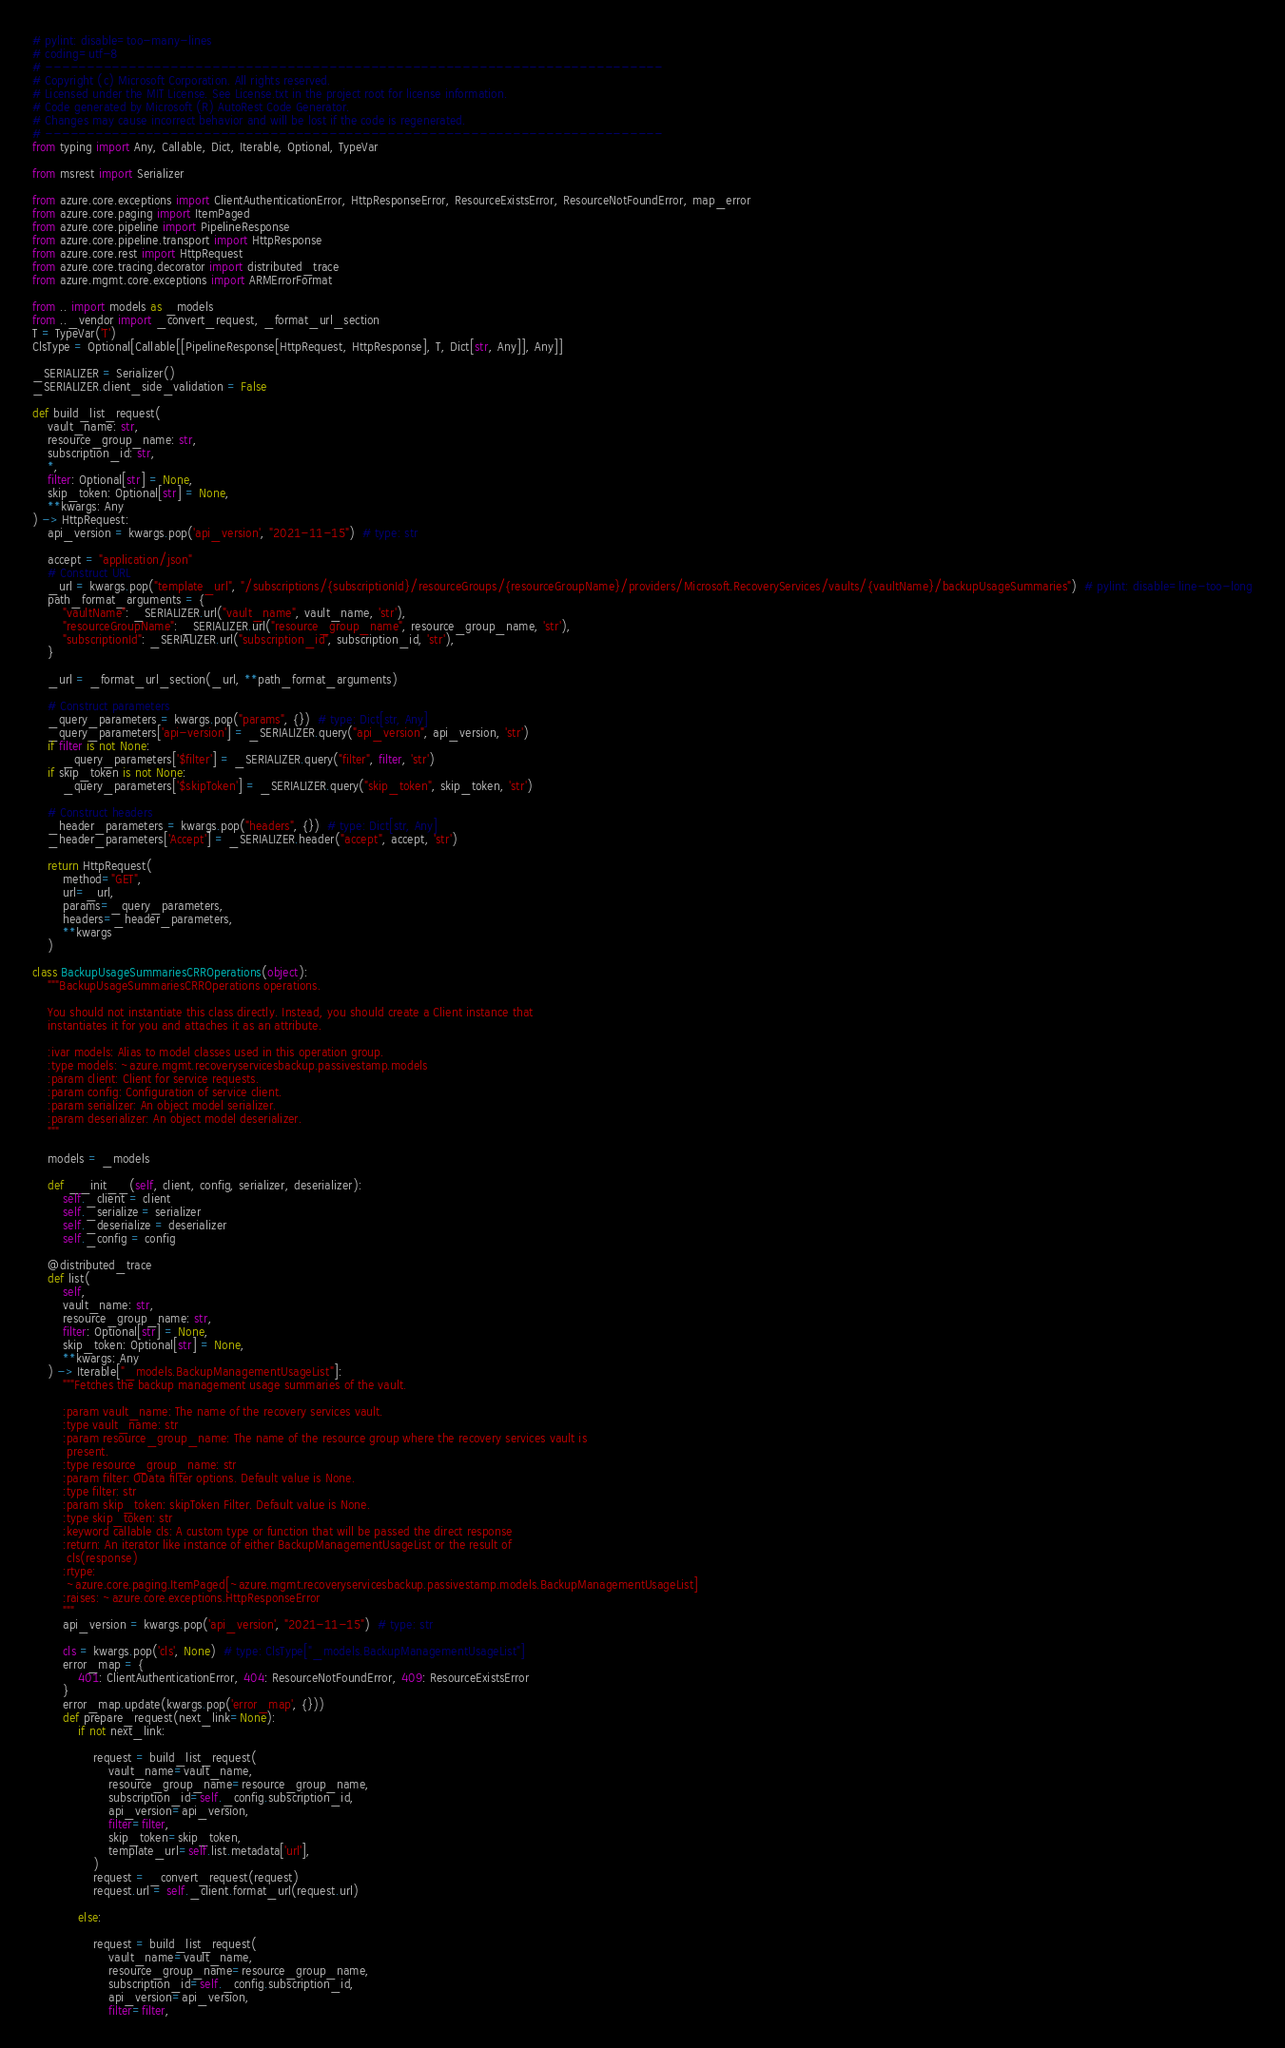Convert code to text. <code><loc_0><loc_0><loc_500><loc_500><_Python_># pylint: disable=too-many-lines
# coding=utf-8
# --------------------------------------------------------------------------
# Copyright (c) Microsoft Corporation. All rights reserved.
# Licensed under the MIT License. See License.txt in the project root for license information.
# Code generated by Microsoft (R) AutoRest Code Generator.
# Changes may cause incorrect behavior and will be lost if the code is regenerated.
# --------------------------------------------------------------------------
from typing import Any, Callable, Dict, Iterable, Optional, TypeVar

from msrest import Serializer

from azure.core.exceptions import ClientAuthenticationError, HttpResponseError, ResourceExistsError, ResourceNotFoundError, map_error
from azure.core.paging import ItemPaged
from azure.core.pipeline import PipelineResponse
from azure.core.pipeline.transport import HttpResponse
from azure.core.rest import HttpRequest
from azure.core.tracing.decorator import distributed_trace
from azure.mgmt.core.exceptions import ARMErrorFormat

from .. import models as _models
from .._vendor import _convert_request, _format_url_section
T = TypeVar('T')
ClsType = Optional[Callable[[PipelineResponse[HttpRequest, HttpResponse], T, Dict[str, Any]], Any]]

_SERIALIZER = Serializer()
_SERIALIZER.client_side_validation = False

def build_list_request(
    vault_name: str,
    resource_group_name: str,
    subscription_id: str,
    *,
    filter: Optional[str] = None,
    skip_token: Optional[str] = None,
    **kwargs: Any
) -> HttpRequest:
    api_version = kwargs.pop('api_version', "2021-11-15")  # type: str

    accept = "application/json"
    # Construct URL
    _url = kwargs.pop("template_url", "/subscriptions/{subscriptionId}/resourceGroups/{resourceGroupName}/providers/Microsoft.RecoveryServices/vaults/{vaultName}/backupUsageSummaries")  # pylint: disable=line-too-long
    path_format_arguments = {
        "vaultName": _SERIALIZER.url("vault_name", vault_name, 'str'),
        "resourceGroupName": _SERIALIZER.url("resource_group_name", resource_group_name, 'str'),
        "subscriptionId": _SERIALIZER.url("subscription_id", subscription_id, 'str'),
    }

    _url = _format_url_section(_url, **path_format_arguments)

    # Construct parameters
    _query_parameters = kwargs.pop("params", {})  # type: Dict[str, Any]
    _query_parameters['api-version'] = _SERIALIZER.query("api_version", api_version, 'str')
    if filter is not None:
        _query_parameters['$filter'] = _SERIALIZER.query("filter", filter, 'str')
    if skip_token is not None:
        _query_parameters['$skipToken'] = _SERIALIZER.query("skip_token", skip_token, 'str')

    # Construct headers
    _header_parameters = kwargs.pop("headers", {})  # type: Dict[str, Any]
    _header_parameters['Accept'] = _SERIALIZER.header("accept", accept, 'str')

    return HttpRequest(
        method="GET",
        url=_url,
        params=_query_parameters,
        headers=_header_parameters,
        **kwargs
    )

class BackupUsageSummariesCRROperations(object):
    """BackupUsageSummariesCRROperations operations.

    You should not instantiate this class directly. Instead, you should create a Client instance that
    instantiates it for you and attaches it as an attribute.

    :ivar models: Alias to model classes used in this operation group.
    :type models: ~azure.mgmt.recoveryservicesbackup.passivestamp.models
    :param client: Client for service requests.
    :param config: Configuration of service client.
    :param serializer: An object model serializer.
    :param deserializer: An object model deserializer.
    """

    models = _models

    def __init__(self, client, config, serializer, deserializer):
        self._client = client
        self._serialize = serializer
        self._deserialize = deserializer
        self._config = config

    @distributed_trace
    def list(
        self,
        vault_name: str,
        resource_group_name: str,
        filter: Optional[str] = None,
        skip_token: Optional[str] = None,
        **kwargs: Any
    ) -> Iterable["_models.BackupManagementUsageList"]:
        """Fetches the backup management usage summaries of the vault.

        :param vault_name: The name of the recovery services vault.
        :type vault_name: str
        :param resource_group_name: The name of the resource group where the recovery services vault is
         present.
        :type resource_group_name: str
        :param filter: OData filter options. Default value is None.
        :type filter: str
        :param skip_token: skipToken Filter. Default value is None.
        :type skip_token: str
        :keyword callable cls: A custom type or function that will be passed the direct response
        :return: An iterator like instance of either BackupManagementUsageList or the result of
         cls(response)
        :rtype:
         ~azure.core.paging.ItemPaged[~azure.mgmt.recoveryservicesbackup.passivestamp.models.BackupManagementUsageList]
        :raises: ~azure.core.exceptions.HttpResponseError
        """
        api_version = kwargs.pop('api_version', "2021-11-15")  # type: str

        cls = kwargs.pop('cls', None)  # type: ClsType["_models.BackupManagementUsageList"]
        error_map = {
            401: ClientAuthenticationError, 404: ResourceNotFoundError, 409: ResourceExistsError
        }
        error_map.update(kwargs.pop('error_map', {}))
        def prepare_request(next_link=None):
            if not next_link:
                
                request = build_list_request(
                    vault_name=vault_name,
                    resource_group_name=resource_group_name,
                    subscription_id=self._config.subscription_id,
                    api_version=api_version,
                    filter=filter,
                    skip_token=skip_token,
                    template_url=self.list.metadata['url'],
                )
                request = _convert_request(request)
                request.url = self._client.format_url(request.url)

            else:
                
                request = build_list_request(
                    vault_name=vault_name,
                    resource_group_name=resource_group_name,
                    subscription_id=self._config.subscription_id,
                    api_version=api_version,
                    filter=filter,</code> 